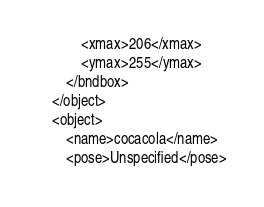Convert code to text. <code><loc_0><loc_0><loc_500><loc_500><_XML_>			<xmax>206</xmax>
			<ymax>255</ymax>
		</bndbox>
	</object>
	<object>
		<name>cocacola</name>
		<pose>Unspecified</pose></code> 